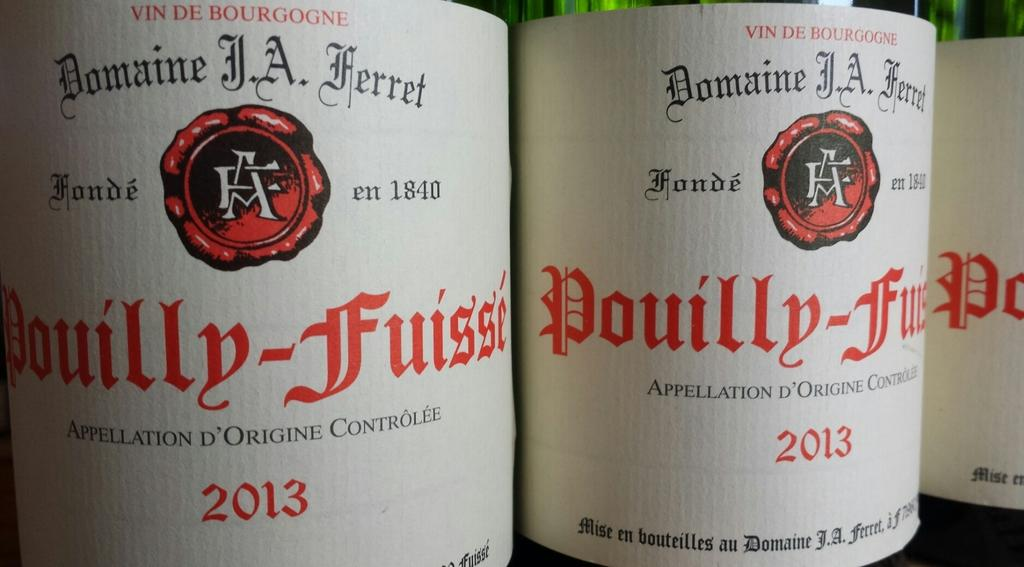Provide a one-sentence caption for the provided image. The label of a bottle named "Douilly-Fuisse" made in 2013. 